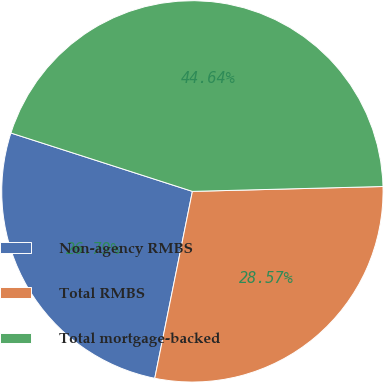Convert chart. <chart><loc_0><loc_0><loc_500><loc_500><pie_chart><fcel>Non-agency RMBS<fcel>Total RMBS<fcel>Total mortgage-backed<nl><fcel>26.79%<fcel>28.57%<fcel>44.64%<nl></chart> 